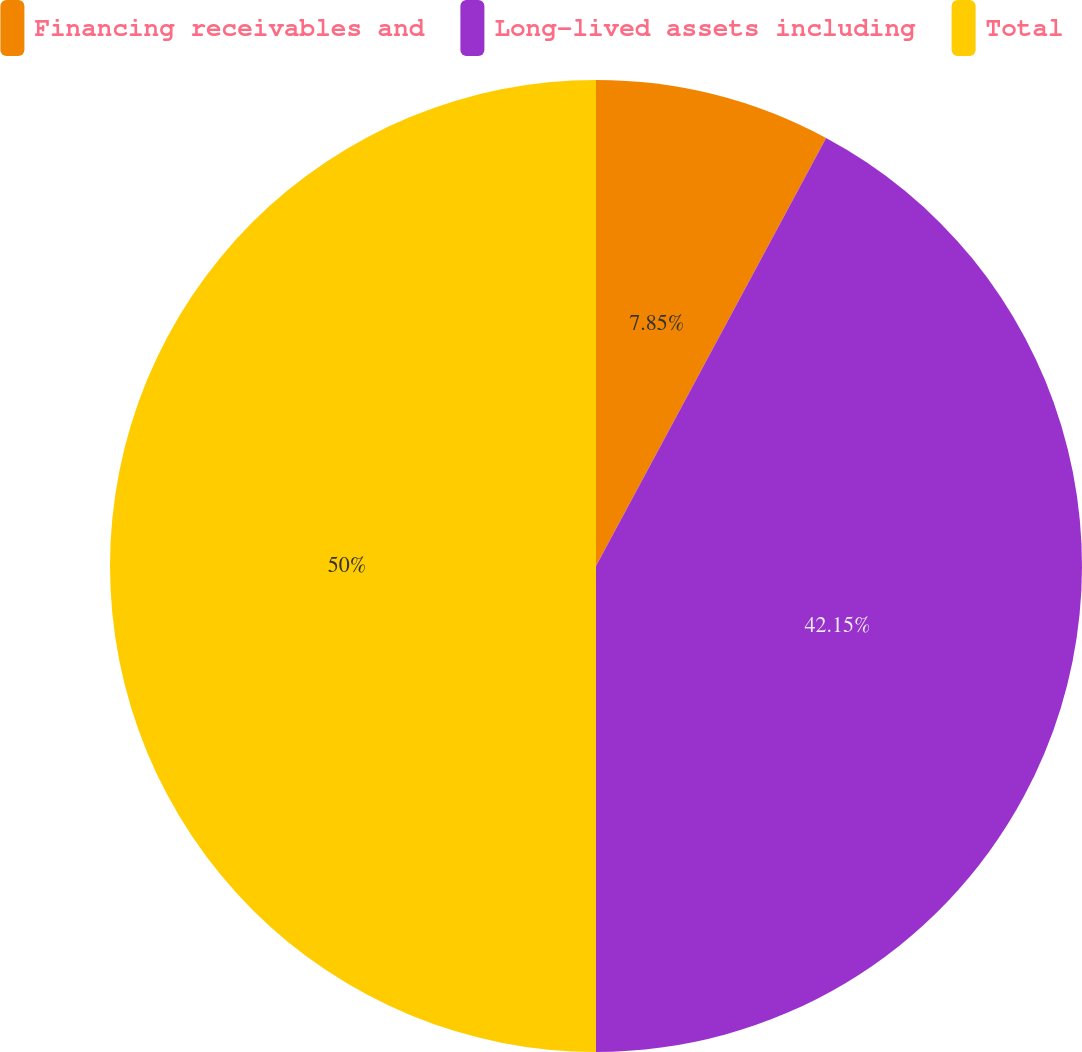<chart> <loc_0><loc_0><loc_500><loc_500><pie_chart><fcel>Financing receivables and<fcel>Long-lived assets including<fcel>Total<nl><fcel>7.85%<fcel>42.15%<fcel>50.0%<nl></chart> 